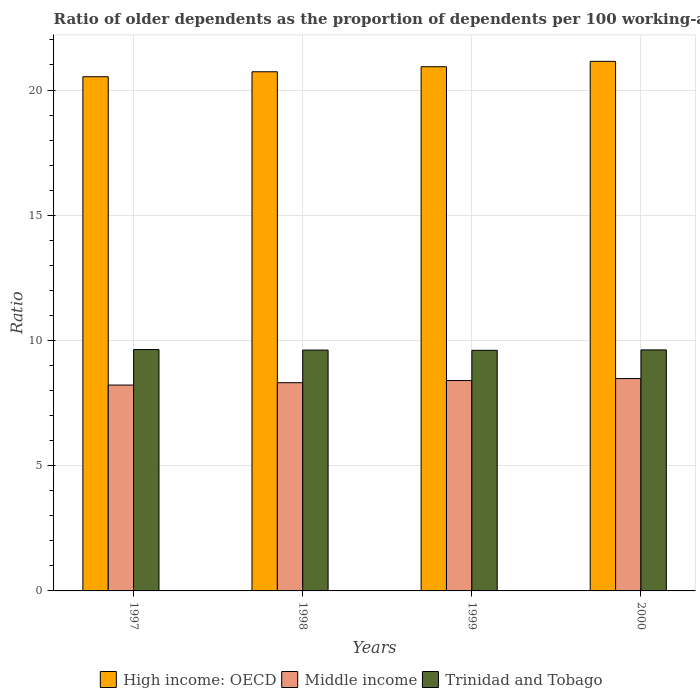How many groups of bars are there?
Give a very brief answer. 4. Are the number of bars on each tick of the X-axis equal?
Offer a terse response. Yes. How many bars are there on the 3rd tick from the left?
Ensure brevity in your answer.  3. What is the age dependency ratio(old) in Trinidad and Tobago in 1999?
Offer a terse response. 9.61. Across all years, what is the maximum age dependency ratio(old) in Trinidad and Tobago?
Give a very brief answer. 9.64. Across all years, what is the minimum age dependency ratio(old) in Trinidad and Tobago?
Your response must be concise. 9.61. In which year was the age dependency ratio(old) in Trinidad and Tobago maximum?
Your answer should be compact. 1997. In which year was the age dependency ratio(old) in High income: OECD minimum?
Offer a terse response. 1997. What is the total age dependency ratio(old) in Trinidad and Tobago in the graph?
Provide a short and direct response. 38.49. What is the difference between the age dependency ratio(old) in Middle income in 1997 and that in 1998?
Give a very brief answer. -0.09. What is the difference between the age dependency ratio(old) in Trinidad and Tobago in 2000 and the age dependency ratio(old) in High income: OECD in 1998?
Provide a succinct answer. -11.11. What is the average age dependency ratio(old) in Trinidad and Tobago per year?
Ensure brevity in your answer.  9.62. In the year 1997, what is the difference between the age dependency ratio(old) in Middle income and age dependency ratio(old) in Trinidad and Tobago?
Offer a terse response. -1.42. In how many years, is the age dependency ratio(old) in Trinidad and Tobago greater than 16?
Ensure brevity in your answer.  0. What is the ratio of the age dependency ratio(old) in Middle income in 1997 to that in 1999?
Your answer should be very brief. 0.98. Is the age dependency ratio(old) in Middle income in 1999 less than that in 2000?
Provide a succinct answer. Yes. Is the difference between the age dependency ratio(old) in Middle income in 1999 and 2000 greater than the difference between the age dependency ratio(old) in Trinidad and Tobago in 1999 and 2000?
Provide a succinct answer. No. What is the difference between the highest and the second highest age dependency ratio(old) in Trinidad and Tobago?
Make the answer very short. 0.01. What is the difference between the highest and the lowest age dependency ratio(old) in Middle income?
Provide a short and direct response. 0.26. In how many years, is the age dependency ratio(old) in High income: OECD greater than the average age dependency ratio(old) in High income: OECD taken over all years?
Offer a very short reply. 2. Is the sum of the age dependency ratio(old) in Middle income in 1998 and 1999 greater than the maximum age dependency ratio(old) in Trinidad and Tobago across all years?
Ensure brevity in your answer.  Yes. What does the 3rd bar from the left in 1997 represents?
Keep it short and to the point. Trinidad and Tobago. What does the 1st bar from the right in 1997 represents?
Ensure brevity in your answer.  Trinidad and Tobago. Is it the case that in every year, the sum of the age dependency ratio(old) in High income: OECD and age dependency ratio(old) in Middle income is greater than the age dependency ratio(old) in Trinidad and Tobago?
Ensure brevity in your answer.  Yes. Are all the bars in the graph horizontal?
Your answer should be very brief. No. How many years are there in the graph?
Your response must be concise. 4. Are the values on the major ticks of Y-axis written in scientific E-notation?
Your answer should be very brief. No. Does the graph contain any zero values?
Offer a very short reply. No. Where does the legend appear in the graph?
Give a very brief answer. Bottom center. How many legend labels are there?
Provide a short and direct response. 3. What is the title of the graph?
Give a very brief answer. Ratio of older dependents as the proportion of dependents per 100 working-age population. Does "Kosovo" appear as one of the legend labels in the graph?
Provide a succinct answer. No. What is the label or title of the X-axis?
Make the answer very short. Years. What is the label or title of the Y-axis?
Your response must be concise. Ratio. What is the Ratio of High income: OECD in 1997?
Keep it short and to the point. 20.53. What is the Ratio in Middle income in 1997?
Your answer should be very brief. 8.22. What is the Ratio of Trinidad and Tobago in 1997?
Your answer should be compact. 9.64. What is the Ratio of High income: OECD in 1998?
Your answer should be very brief. 20.73. What is the Ratio of Middle income in 1998?
Keep it short and to the point. 8.31. What is the Ratio of Trinidad and Tobago in 1998?
Provide a short and direct response. 9.62. What is the Ratio in High income: OECD in 1999?
Make the answer very short. 20.93. What is the Ratio in Middle income in 1999?
Offer a terse response. 8.4. What is the Ratio in Trinidad and Tobago in 1999?
Offer a terse response. 9.61. What is the Ratio in High income: OECD in 2000?
Your response must be concise. 21.15. What is the Ratio in Middle income in 2000?
Your response must be concise. 8.48. What is the Ratio in Trinidad and Tobago in 2000?
Offer a very short reply. 9.62. Across all years, what is the maximum Ratio of High income: OECD?
Offer a terse response. 21.15. Across all years, what is the maximum Ratio of Middle income?
Keep it short and to the point. 8.48. Across all years, what is the maximum Ratio in Trinidad and Tobago?
Ensure brevity in your answer.  9.64. Across all years, what is the minimum Ratio in High income: OECD?
Your answer should be very brief. 20.53. Across all years, what is the minimum Ratio of Middle income?
Keep it short and to the point. 8.22. Across all years, what is the minimum Ratio of Trinidad and Tobago?
Your answer should be compact. 9.61. What is the total Ratio of High income: OECD in the graph?
Your answer should be compact. 83.34. What is the total Ratio of Middle income in the graph?
Provide a succinct answer. 33.41. What is the total Ratio in Trinidad and Tobago in the graph?
Keep it short and to the point. 38.49. What is the difference between the Ratio of High income: OECD in 1997 and that in 1998?
Provide a short and direct response. -0.2. What is the difference between the Ratio in Middle income in 1997 and that in 1998?
Give a very brief answer. -0.09. What is the difference between the Ratio in Trinidad and Tobago in 1997 and that in 1998?
Make the answer very short. 0.02. What is the difference between the Ratio of High income: OECD in 1997 and that in 1999?
Ensure brevity in your answer.  -0.4. What is the difference between the Ratio in Middle income in 1997 and that in 1999?
Provide a succinct answer. -0.18. What is the difference between the Ratio in Trinidad and Tobago in 1997 and that in 1999?
Your answer should be very brief. 0.03. What is the difference between the Ratio in High income: OECD in 1997 and that in 2000?
Make the answer very short. -0.61. What is the difference between the Ratio of Middle income in 1997 and that in 2000?
Provide a succinct answer. -0.26. What is the difference between the Ratio in Trinidad and Tobago in 1997 and that in 2000?
Your answer should be very brief. 0.01. What is the difference between the Ratio of High income: OECD in 1998 and that in 1999?
Your answer should be compact. -0.2. What is the difference between the Ratio in Middle income in 1998 and that in 1999?
Give a very brief answer. -0.09. What is the difference between the Ratio of Trinidad and Tobago in 1998 and that in 1999?
Provide a succinct answer. 0.01. What is the difference between the Ratio of High income: OECD in 1998 and that in 2000?
Offer a very short reply. -0.42. What is the difference between the Ratio in Middle income in 1998 and that in 2000?
Make the answer very short. -0.16. What is the difference between the Ratio of Trinidad and Tobago in 1998 and that in 2000?
Your answer should be compact. -0.01. What is the difference between the Ratio of High income: OECD in 1999 and that in 2000?
Offer a terse response. -0.21. What is the difference between the Ratio in Middle income in 1999 and that in 2000?
Give a very brief answer. -0.08. What is the difference between the Ratio of Trinidad and Tobago in 1999 and that in 2000?
Provide a short and direct response. -0.02. What is the difference between the Ratio of High income: OECD in 1997 and the Ratio of Middle income in 1998?
Offer a very short reply. 12.22. What is the difference between the Ratio of High income: OECD in 1997 and the Ratio of Trinidad and Tobago in 1998?
Your response must be concise. 10.91. What is the difference between the Ratio in Middle income in 1997 and the Ratio in Trinidad and Tobago in 1998?
Your answer should be very brief. -1.4. What is the difference between the Ratio of High income: OECD in 1997 and the Ratio of Middle income in 1999?
Provide a succinct answer. 12.13. What is the difference between the Ratio in High income: OECD in 1997 and the Ratio in Trinidad and Tobago in 1999?
Offer a very short reply. 10.92. What is the difference between the Ratio in Middle income in 1997 and the Ratio in Trinidad and Tobago in 1999?
Give a very brief answer. -1.39. What is the difference between the Ratio in High income: OECD in 1997 and the Ratio in Middle income in 2000?
Provide a short and direct response. 12.05. What is the difference between the Ratio in High income: OECD in 1997 and the Ratio in Trinidad and Tobago in 2000?
Make the answer very short. 10.91. What is the difference between the Ratio of Middle income in 1997 and the Ratio of Trinidad and Tobago in 2000?
Your response must be concise. -1.4. What is the difference between the Ratio in High income: OECD in 1998 and the Ratio in Middle income in 1999?
Keep it short and to the point. 12.33. What is the difference between the Ratio of High income: OECD in 1998 and the Ratio of Trinidad and Tobago in 1999?
Provide a short and direct response. 11.12. What is the difference between the Ratio of Middle income in 1998 and the Ratio of Trinidad and Tobago in 1999?
Ensure brevity in your answer.  -1.29. What is the difference between the Ratio of High income: OECD in 1998 and the Ratio of Middle income in 2000?
Your answer should be compact. 12.25. What is the difference between the Ratio of High income: OECD in 1998 and the Ratio of Trinidad and Tobago in 2000?
Keep it short and to the point. 11.11. What is the difference between the Ratio in Middle income in 1998 and the Ratio in Trinidad and Tobago in 2000?
Your answer should be very brief. -1.31. What is the difference between the Ratio in High income: OECD in 1999 and the Ratio in Middle income in 2000?
Provide a succinct answer. 12.45. What is the difference between the Ratio of High income: OECD in 1999 and the Ratio of Trinidad and Tobago in 2000?
Your answer should be compact. 11.31. What is the difference between the Ratio of Middle income in 1999 and the Ratio of Trinidad and Tobago in 2000?
Give a very brief answer. -1.22. What is the average Ratio in High income: OECD per year?
Provide a succinct answer. 20.83. What is the average Ratio in Middle income per year?
Provide a succinct answer. 8.35. What is the average Ratio of Trinidad and Tobago per year?
Your answer should be very brief. 9.62. In the year 1997, what is the difference between the Ratio of High income: OECD and Ratio of Middle income?
Provide a short and direct response. 12.31. In the year 1997, what is the difference between the Ratio in High income: OECD and Ratio in Trinidad and Tobago?
Provide a short and direct response. 10.89. In the year 1997, what is the difference between the Ratio of Middle income and Ratio of Trinidad and Tobago?
Make the answer very short. -1.42. In the year 1998, what is the difference between the Ratio in High income: OECD and Ratio in Middle income?
Your answer should be very brief. 12.42. In the year 1998, what is the difference between the Ratio in High income: OECD and Ratio in Trinidad and Tobago?
Offer a terse response. 11.11. In the year 1998, what is the difference between the Ratio in Middle income and Ratio in Trinidad and Tobago?
Your answer should be very brief. -1.3. In the year 1999, what is the difference between the Ratio of High income: OECD and Ratio of Middle income?
Provide a succinct answer. 12.53. In the year 1999, what is the difference between the Ratio in High income: OECD and Ratio in Trinidad and Tobago?
Your response must be concise. 11.32. In the year 1999, what is the difference between the Ratio of Middle income and Ratio of Trinidad and Tobago?
Provide a short and direct response. -1.21. In the year 2000, what is the difference between the Ratio in High income: OECD and Ratio in Middle income?
Offer a very short reply. 12.67. In the year 2000, what is the difference between the Ratio of High income: OECD and Ratio of Trinidad and Tobago?
Provide a short and direct response. 11.52. In the year 2000, what is the difference between the Ratio in Middle income and Ratio in Trinidad and Tobago?
Keep it short and to the point. -1.15. What is the ratio of the Ratio of High income: OECD in 1997 to that in 1998?
Give a very brief answer. 0.99. What is the ratio of the Ratio in Middle income in 1997 to that in 1998?
Offer a terse response. 0.99. What is the ratio of the Ratio of High income: OECD in 1997 to that in 1999?
Your answer should be very brief. 0.98. What is the ratio of the Ratio of Middle income in 1997 to that in 1999?
Your answer should be very brief. 0.98. What is the ratio of the Ratio of Trinidad and Tobago in 1997 to that in 1999?
Make the answer very short. 1. What is the ratio of the Ratio of Middle income in 1997 to that in 2000?
Make the answer very short. 0.97. What is the ratio of the Ratio in High income: OECD in 1998 to that in 2000?
Offer a very short reply. 0.98. What is the ratio of the Ratio of Middle income in 1998 to that in 2000?
Ensure brevity in your answer.  0.98. What is the ratio of the Ratio in High income: OECD in 1999 to that in 2000?
Provide a succinct answer. 0.99. What is the ratio of the Ratio of Middle income in 1999 to that in 2000?
Your answer should be compact. 0.99. What is the difference between the highest and the second highest Ratio in High income: OECD?
Offer a terse response. 0.21. What is the difference between the highest and the second highest Ratio in Middle income?
Your response must be concise. 0.08. What is the difference between the highest and the second highest Ratio in Trinidad and Tobago?
Offer a terse response. 0.01. What is the difference between the highest and the lowest Ratio in High income: OECD?
Offer a very short reply. 0.61. What is the difference between the highest and the lowest Ratio of Middle income?
Offer a very short reply. 0.26. What is the difference between the highest and the lowest Ratio of Trinidad and Tobago?
Your answer should be compact. 0.03. 